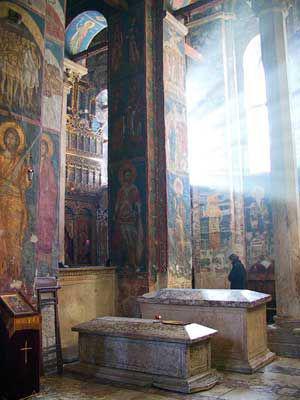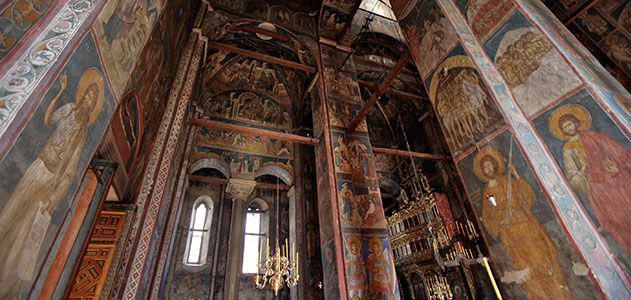The first image is the image on the left, the second image is the image on the right. For the images displayed, is the sentence "There is a person in the image on the left." factually correct? Answer yes or no. Yes. The first image is the image on the left, the second image is the image on the right. For the images displayed, is the sentence "Clear arch-topped windows are featured in at least one image." factually correct? Answer yes or no. Yes. 